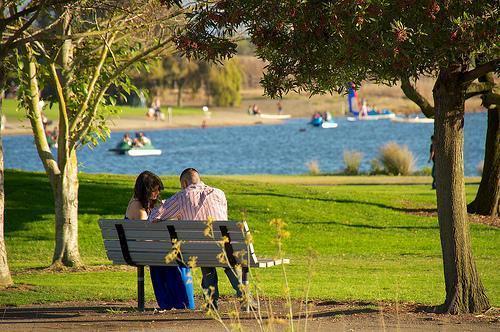How many people are sitting?
Give a very brief answer. 2. 